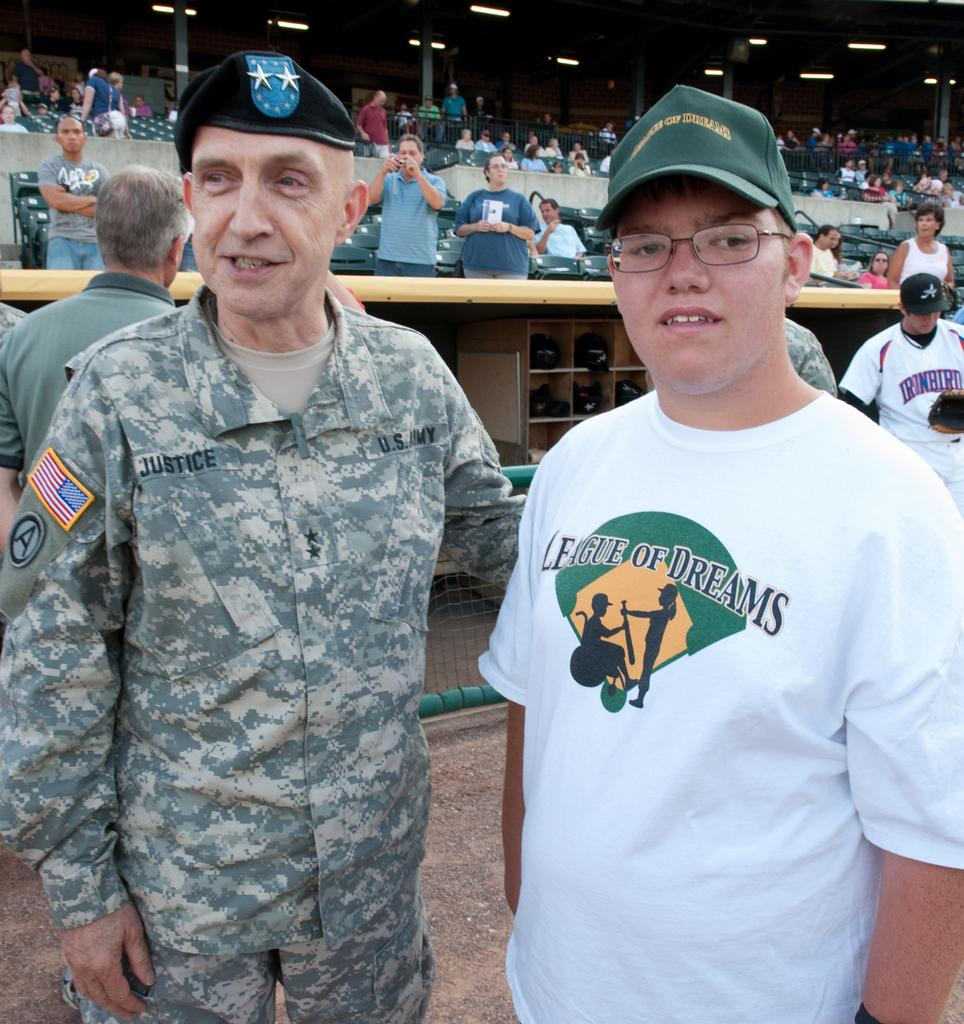Provide a one-sentence caption for the provided image. Army soldier Justice standing with a boy wearing a League of Dreams tshirt. 